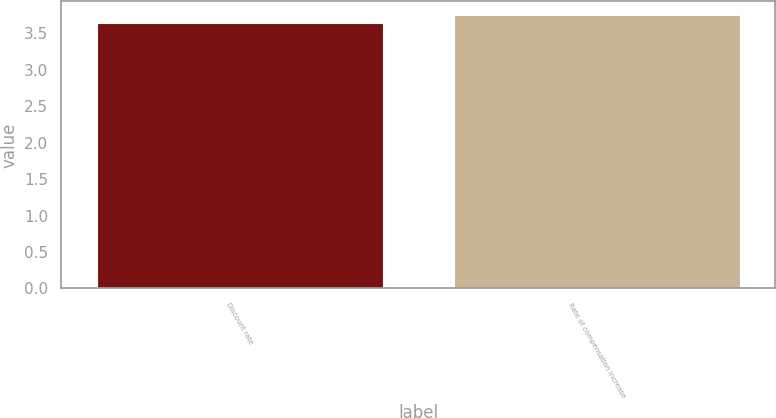<chart> <loc_0><loc_0><loc_500><loc_500><bar_chart><fcel>Discount rate<fcel>Rate of compensation increase<nl><fcel>3.64<fcel>3.75<nl></chart> 